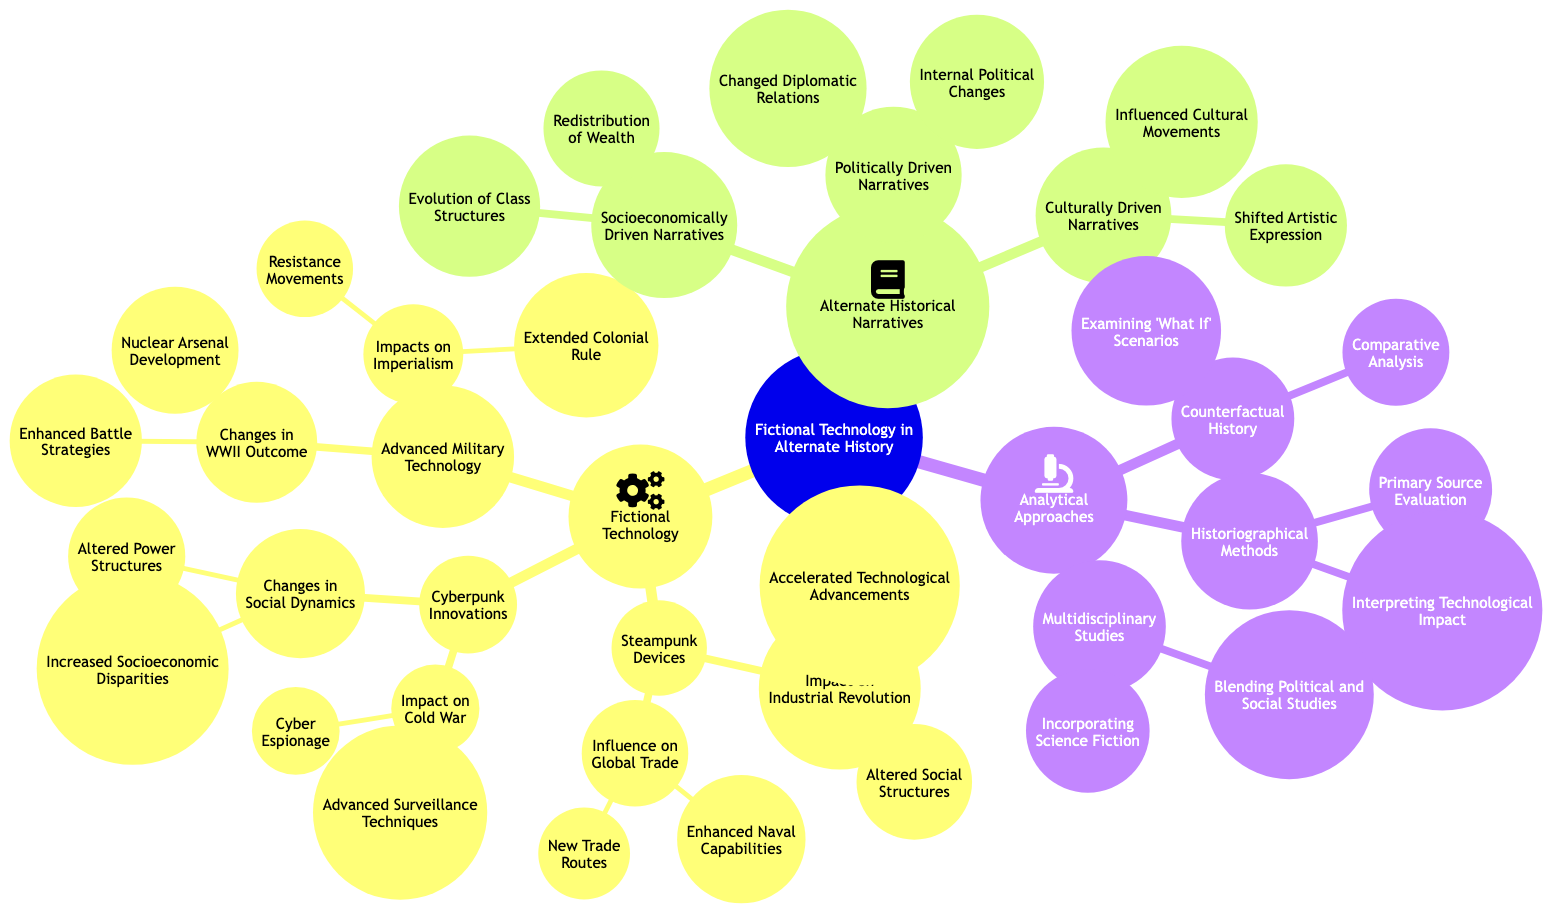What are the two main categories of fictional technology? The diagram clearly shows that the two main categories of fictional technology are Steampunk Devices and Cyberpunk Innovations. Both of these categories are located directly under the main node titled "Fictional Technology."
Answer: Steampunk Devices, Cyberpunk Innovations How many sub-elements are listed under Advanced Military Technology? The diagram reveals that under the node "Advanced Military Technology," there are two sub-elements: "Changes in WWII Outcome" and "Impacts on Imperialism." Thus, there are a total of two sub-elements associated with this category.
Answer: 2 What is the primary effect of Steampunk Devices on the Industrial Revolution? From the diagram, it is evident that the primary effects of Steampunk Devices on the Industrial Revolution include "Accelerated Technological Advancements" and "Altered Social Structures." Since the question is about the primary effect, we can select the first one, which directly correlates to the impact.
Answer: Accelerated Technological Advancements Which alternate historical narrative focuses on cultural influences? Referring to the diagram, the alternate historical narrative that centers on cultural influences is identified as "Culturally Driven Narratives." This node highlights aspects related to cultural movements and artistic expression.
Answer: Culturally Driven Narratives What are the two types of analytical approaches listed in the diagram? Upon examining the diagram, it can be seen that the two analytical approaches are "Counterfactual History" and "Historiographical Methods." Both approaches appear as sub-elements under the main category "Analytical Approaches."
Answer: Counterfactual History, Historiographical Methods What consequence does Advanced Military Technology have on WWII outcomes? The diagram outlines two specific consequences of Advanced Military Technology on WWII outcomes: "Nuclear Arsenal Development" and "Enhanced Battle Strategies." Since we are seeking a consequence, we can refer to either of these, but typically "Nuclear Arsenal Development" is often seen as a critical consequence.
Answer: Nuclear Arsenal Development What type of narratives does increased socioeconomic disparities relate to? The diagram indicates that increased socioeconomic disparities are a part of "Changes in Social Dynamics" under the "Cyberpunk Innovations," which suggests that this aspect relates to "Socioeconomically Driven Narratives."
Answer: Socioeconomically Driven Narratives How many elements are listed under the analytical approaches? By looking at the "Analytical Approaches" node, we can see that there are three main elements listed: "Counterfactual History," "Historiographical Methods," and "Multidisciplinary Studies." Thus, we can conclude there are three elements in total.
Answer: 3 